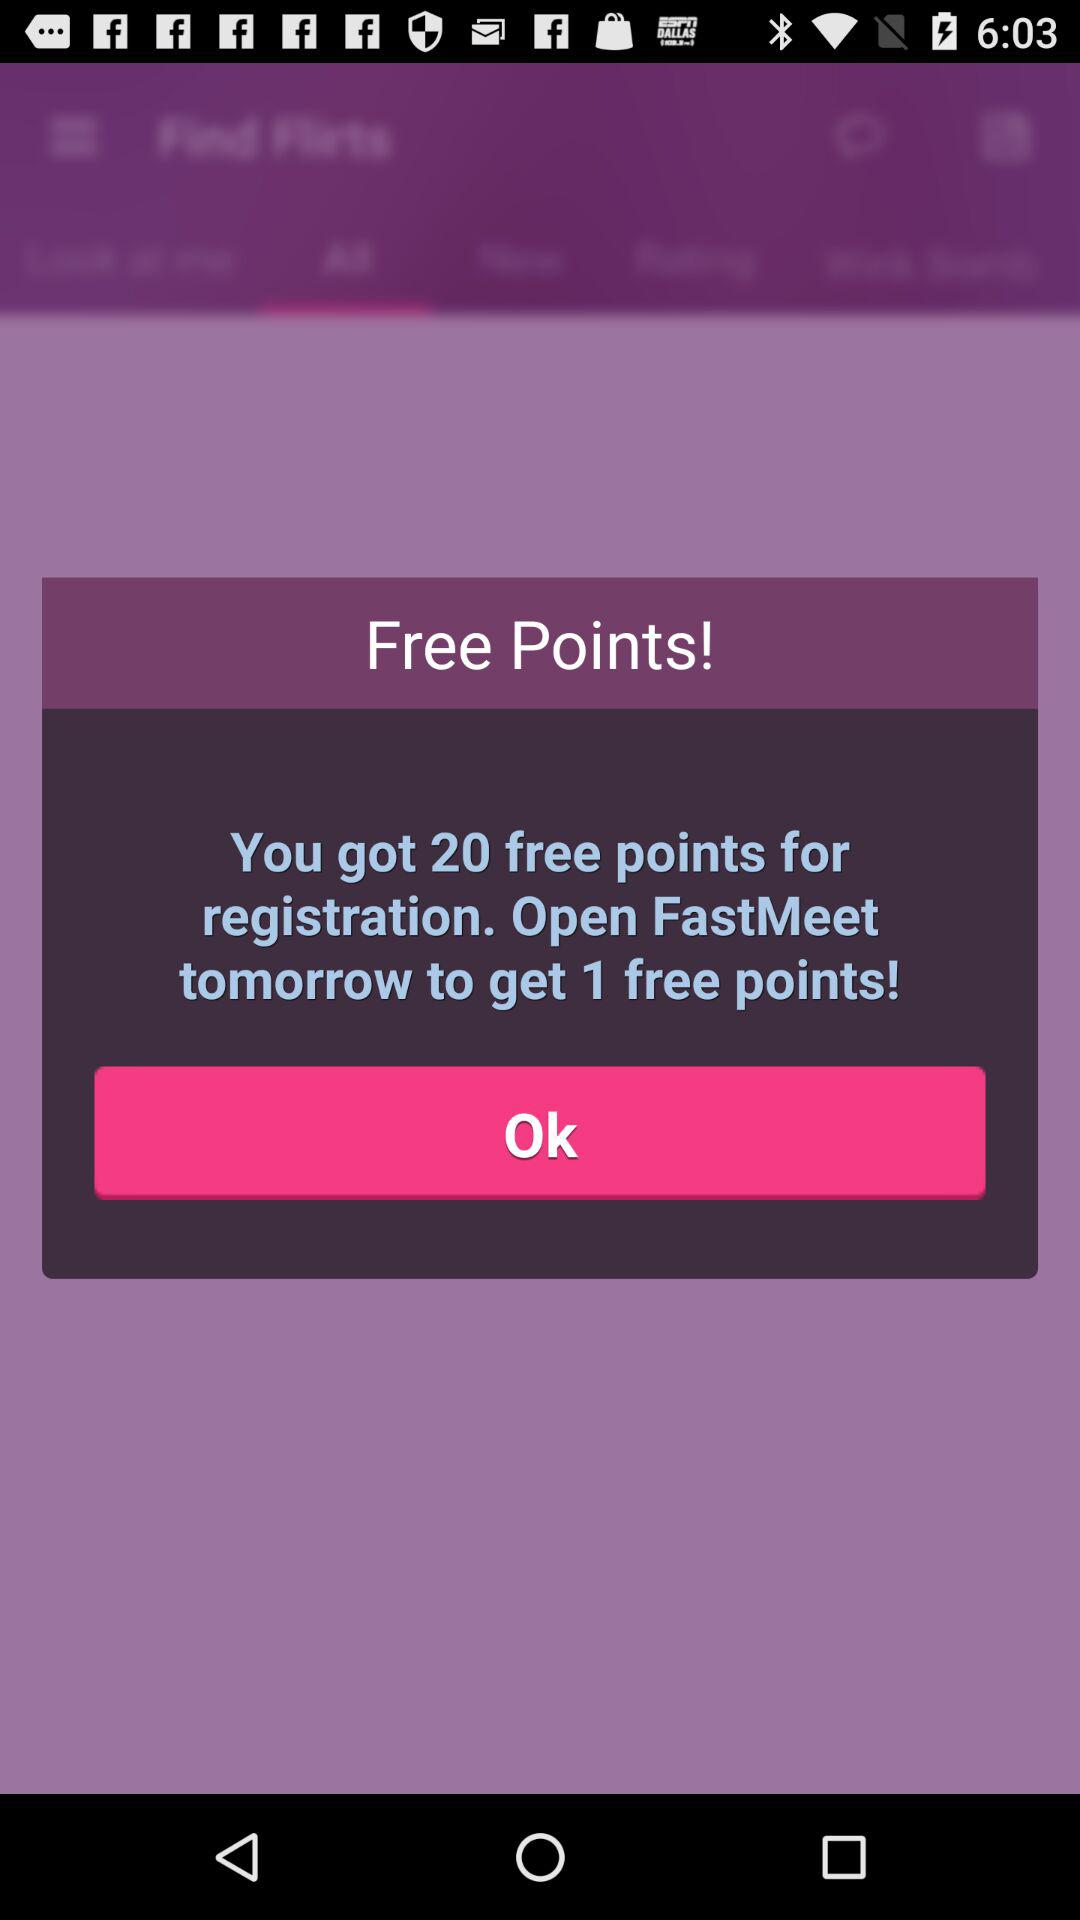How many points will you get after opening the "FastMeet" app tomorrow? You will get 1 point after opening the "FastMeet" app tomorrow. 